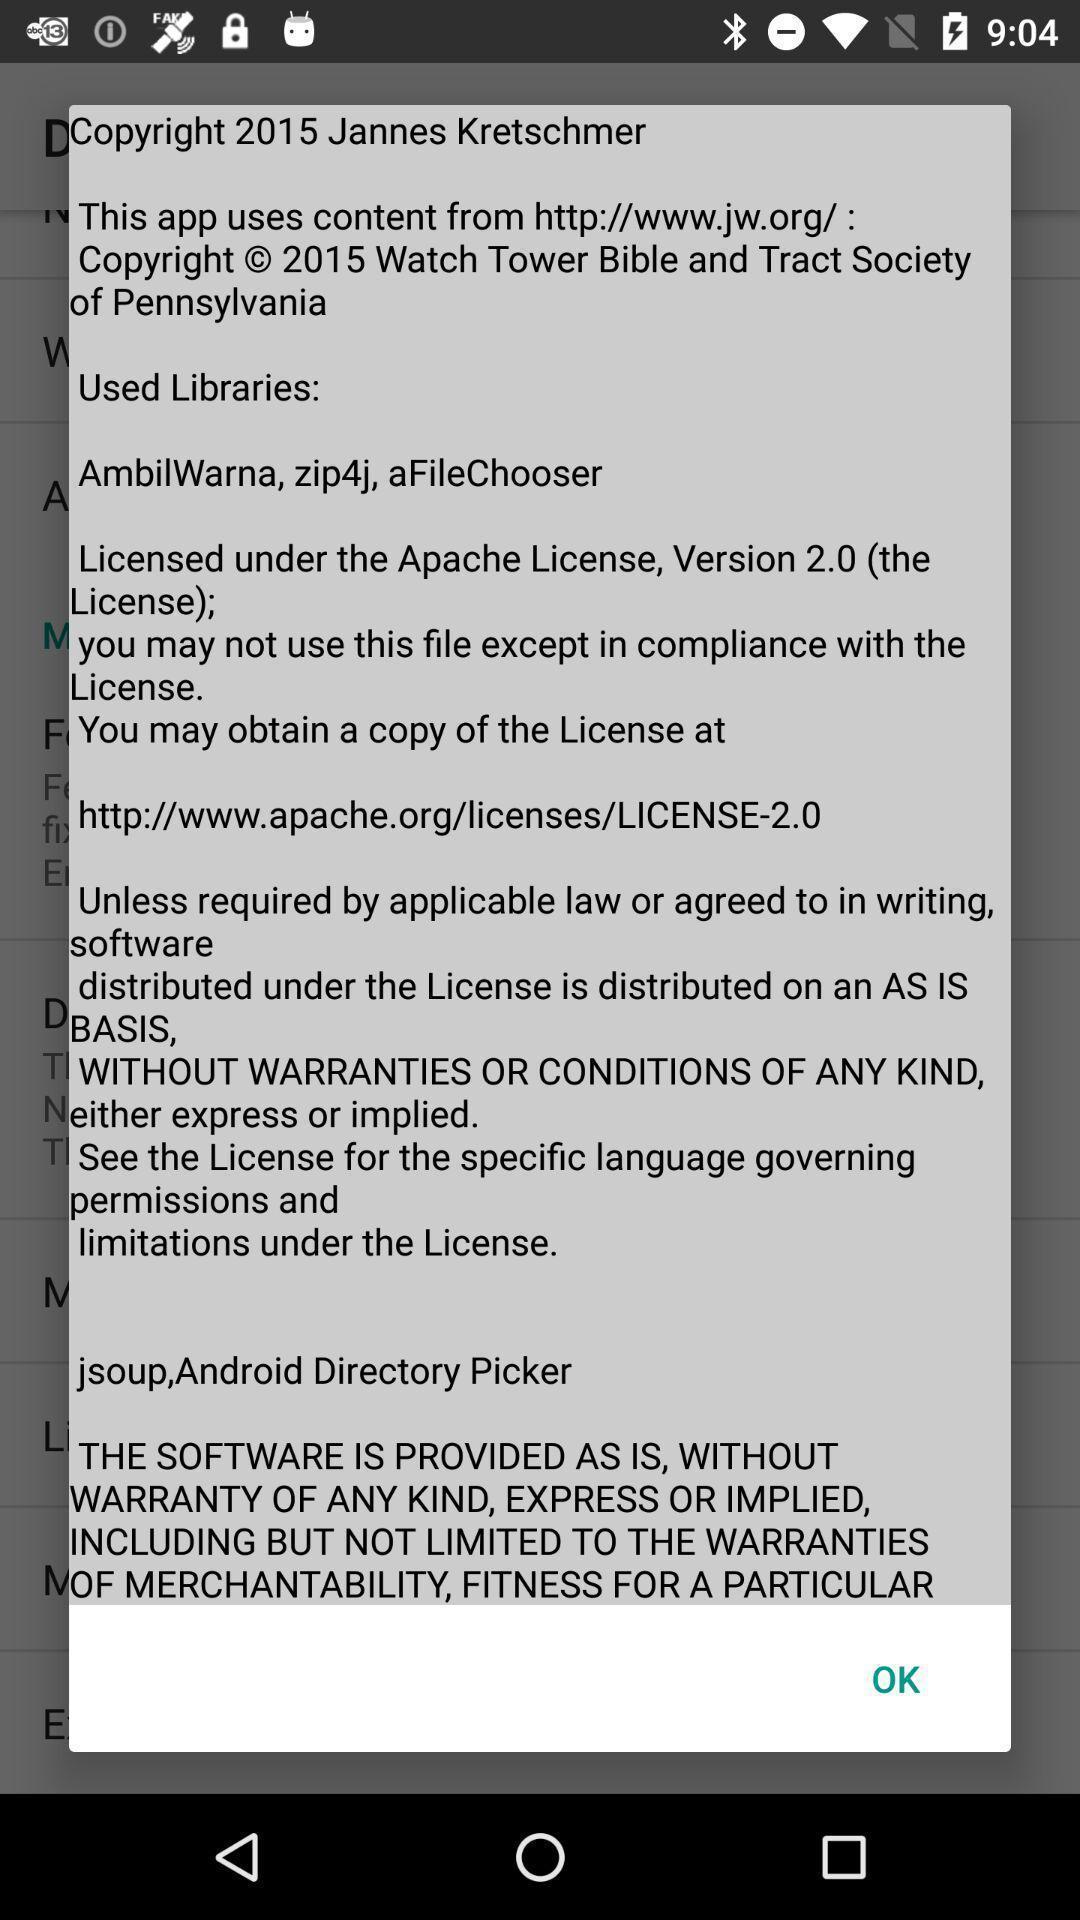What can you discern from this picture? Pop up with app information. 